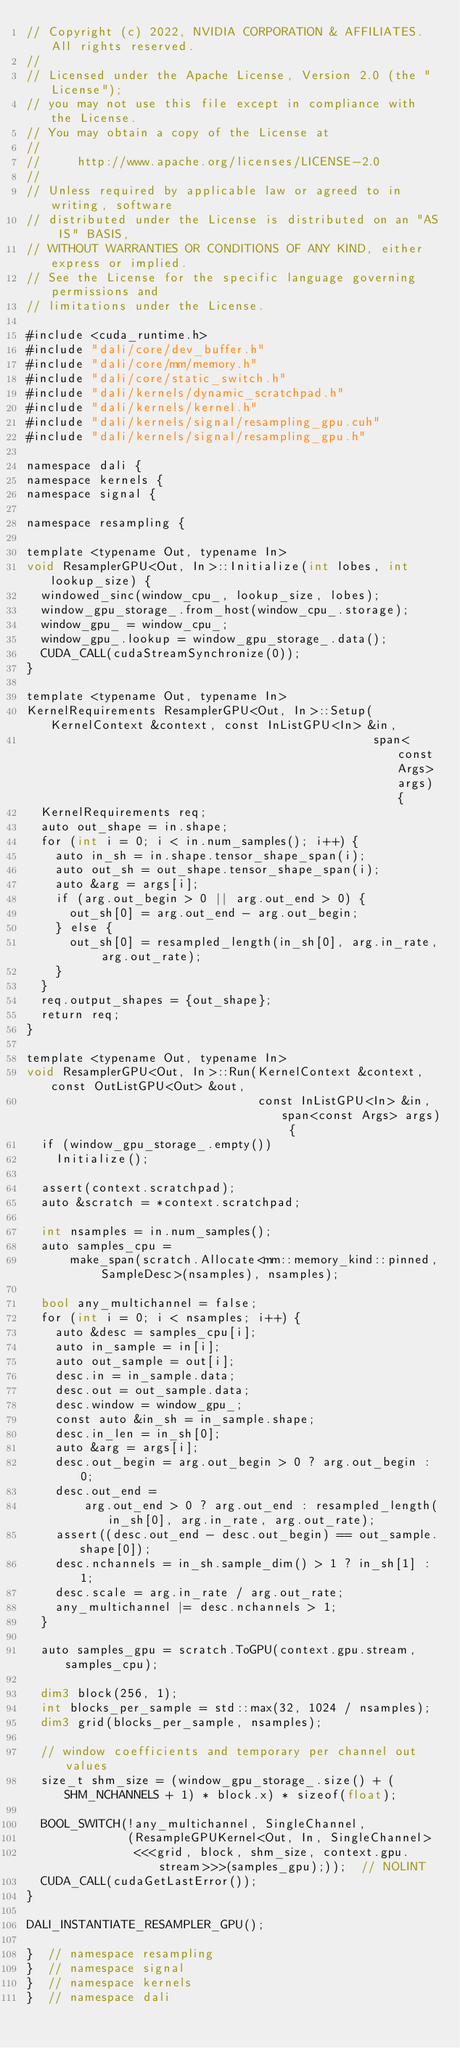<code> <loc_0><loc_0><loc_500><loc_500><_Cuda_>// Copyright (c) 2022, NVIDIA CORPORATION & AFFILIATES. All rights reserved.
//
// Licensed under the Apache License, Version 2.0 (the "License");
// you may not use this file except in compliance with the License.
// You may obtain a copy of the License at
//
//     http://www.apache.org/licenses/LICENSE-2.0
//
// Unless required by applicable law or agreed to in writing, software
// distributed under the License is distributed on an "AS IS" BASIS,
// WITHOUT WARRANTIES OR CONDITIONS OF ANY KIND, either express or implied.
// See the License for the specific language governing permissions and
// limitations under the License.

#include <cuda_runtime.h>
#include "dali/core/dev_buffer.h"
#include "dali/core/mm/memory.h"
#include "dali/core/static_switch.h"
#include "dali/kernels/dynamic_scratchpad.h"
#include "dali/kernels/kernel.h"
#include "dali/kernels/signal/resampling_gpu.cuh"
#include "dali/kernels/signal/resampling_gpu.h"

namespace dali {
namespace kernels {
namespace signal {

namespace resampling {

template <typename Out, typename In>
void ResamplerGPU<Out, In>::Initialize(int lobes, int lookup_size) {
  windowed_sinc(window_cpu_, lookup_size, lobes);
  window_gpu_storage_.from_host(window_cpu_.storage);
  window_gpu_ = window_cpu_;
  window_gpu_.lookup = window_gpu_storage_.data();
  CUDA_CALL(cudaStreamSynchronize(0));
}

template <typename Out, typename In>
KernelRequirements ResamplerGPU<Out, In>::Setup(KernelContext &context, const InListGPU<In> &in,
                                                span<const Args> args) {
  KernelRequirements req;
  auto out_shape = in.shape;
  for (int i = 0; i < in.num_samples(); i++) {
    auto in_sh = in.shape.tensor_shape_span(i);
    auto out_sh = out_shape.tensor_shape_span(i);
    auto &arg = args[i];
    if (arg.out_begin > 0 || arg.out_end > 0) {
      out_sh[0] = arg.out_end - arg.out_begin;
    } else {
      out_sh[0] = resampled_length(in_sh[0], arg.in_rate, arg.out_rate);
    }
  }
  req.output_shapes = {out_shape};
  return req;
}

template <typename Out, typename In>
void ResamplerGPU<Out, In>::Run(KernelContext &context, const OutListGPU<Out> &out,
                                const InListGPU<In> &in, span<const Args> args) {
  if (window_gpu_storage_.empty())
    Initialize();

  assert(context.scratchpad);
  auto &scratch = *context.scratchpad;

  int nsamples = in.num_samples();
  auto samples_cpu =
      make_span(scratch.Allocate<mm::memory_kind::pinned, SampleDesc>(nsamples), nsamples);

  bool any_multichannel = false;
  for (int i = 0; i < nsamples; i++) {
    auto &desc = samples_cpu[i];
    auto in_sample = in[i];
    auto out_sample = out[i];
    desc.in = in_sample.data;
    desc.out = out_sample.data;
    desc.window = window_gpu_;
    const auto &in_sh = in_sample.shape;
    desc.in_len = in_sh[0];
    auto &arg = args[i];
    desc.out_begin = arg.out_begin > 0 ? arg.out_begin : 0;
    desc.out_end =
        arg.out_end > 0 ? arg.out_end : resampled_length(in_sh[0], arg.in_rate, arg.out_rate);
    assert((desc.out_end - desc.out_begin) == out_sample.shape[0]);
    desc.nchannels = in_sh.sample_dim() > 1 ? in_sh[1] : 1;
    desc.scale = arg.in_rate / arg.out_rate;
    any_multichannel |= desc.nchannels > 1;
  }

  auto samples_gpu = scratch.ToGPU(context.gpu.stream, samples_cpu);

  dim3 block(256, 1);
  int blocks_per_sample = std::max(32, 1024 / nsamples);
  dim3 grid(blocks_per_sample, nsamples);

  // window coefficients and temporary per channel out values
  size_t shm_size = (window_gpu_storage_.size() + (SHM_NCHANNELS + 1) * block.x) * sizeof(float);

  BOOL_SWITCH(!any_multichannel, SingleChannel,
              (ResampleGPUKernel<Out, In, SingleChannel>
               <<<grid, block, shm_size, context.gpu.stream>>>(samples_gpu);));  // NOLINT
  CUDA_CALL(cudaGetLastError());
}

DALI_INSTANTIATE_RESAMPLER_GPU();

}  // namespace resampling
}  // namespace signal
}  // namespace kernels
}  // namespace dali
</code> 